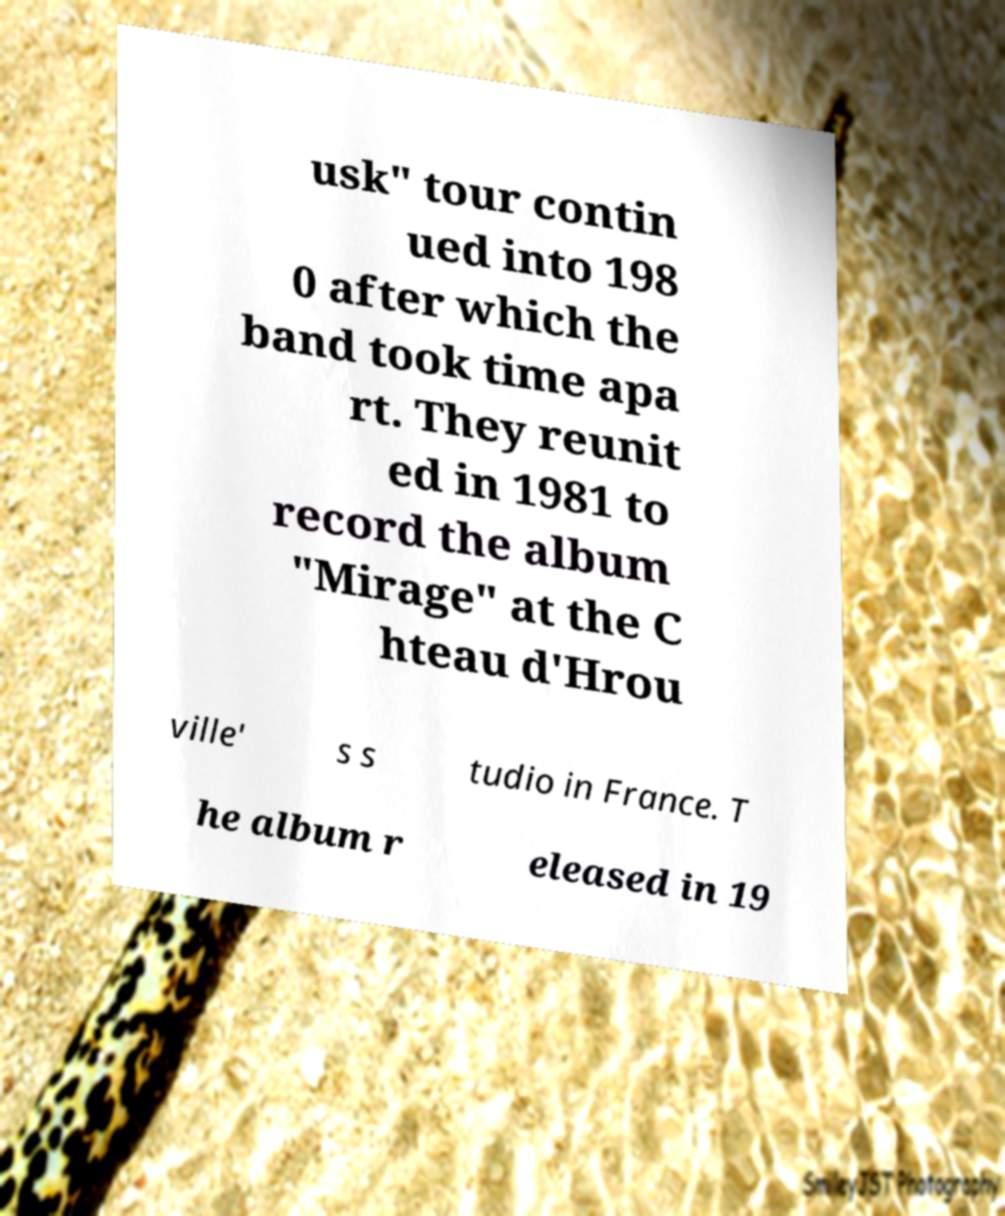Please identify and transcribe the text found in this image. usk" tour contin ued into 198 0 after which the band took time apa rt. They reunit ed in 1981 to record the album "Mirage" at the C hteau d'Hrou ville' s s tudio in France. T he album r eleased in 19 